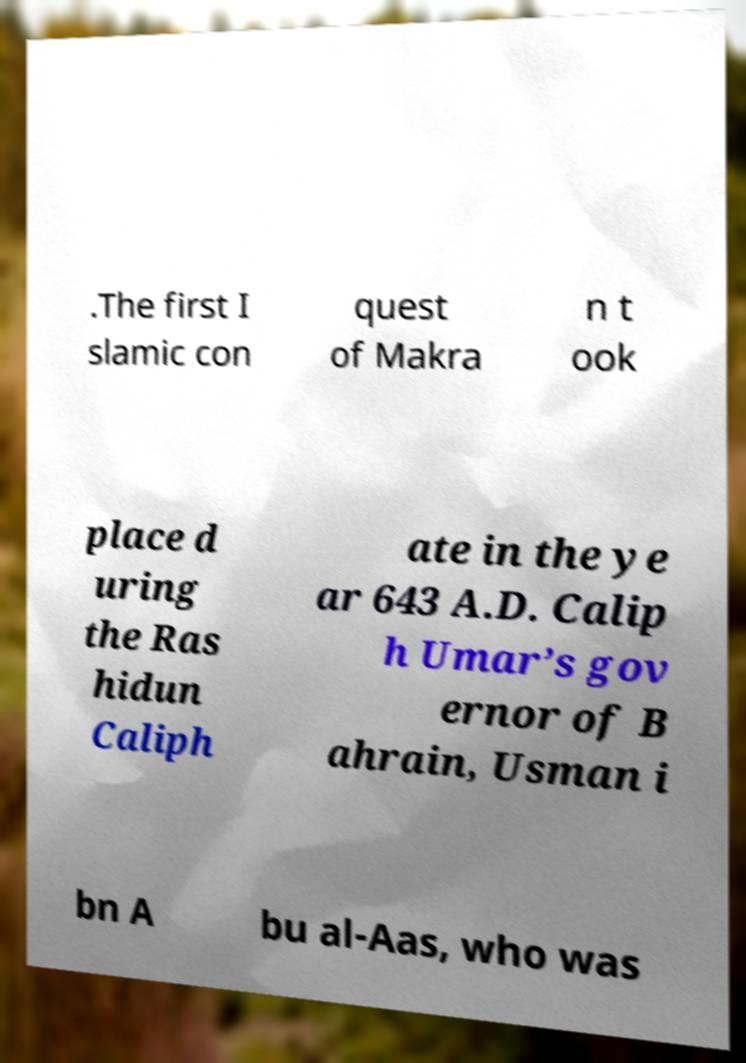For documentation purposes, I need the text within this image transcribed. Could you provide that? .The first I slamic con quest of Makra n t ook place d uring the Ras hidun Caliph ate in the ye ar 643 A.D. Calip h Umar’s gov ernor of B ahrain, Usman i bn A bu al-Aas, who was 